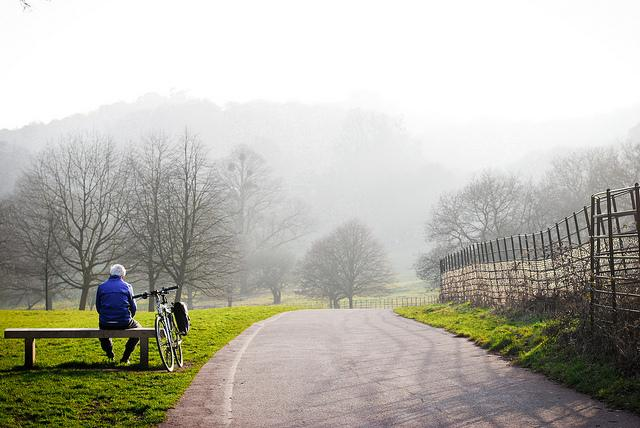Why is the sky so hazy? Please explain your reasoning. fog. A path with trees behind a haze in the air is lined with a fence and a bench on the other side. 